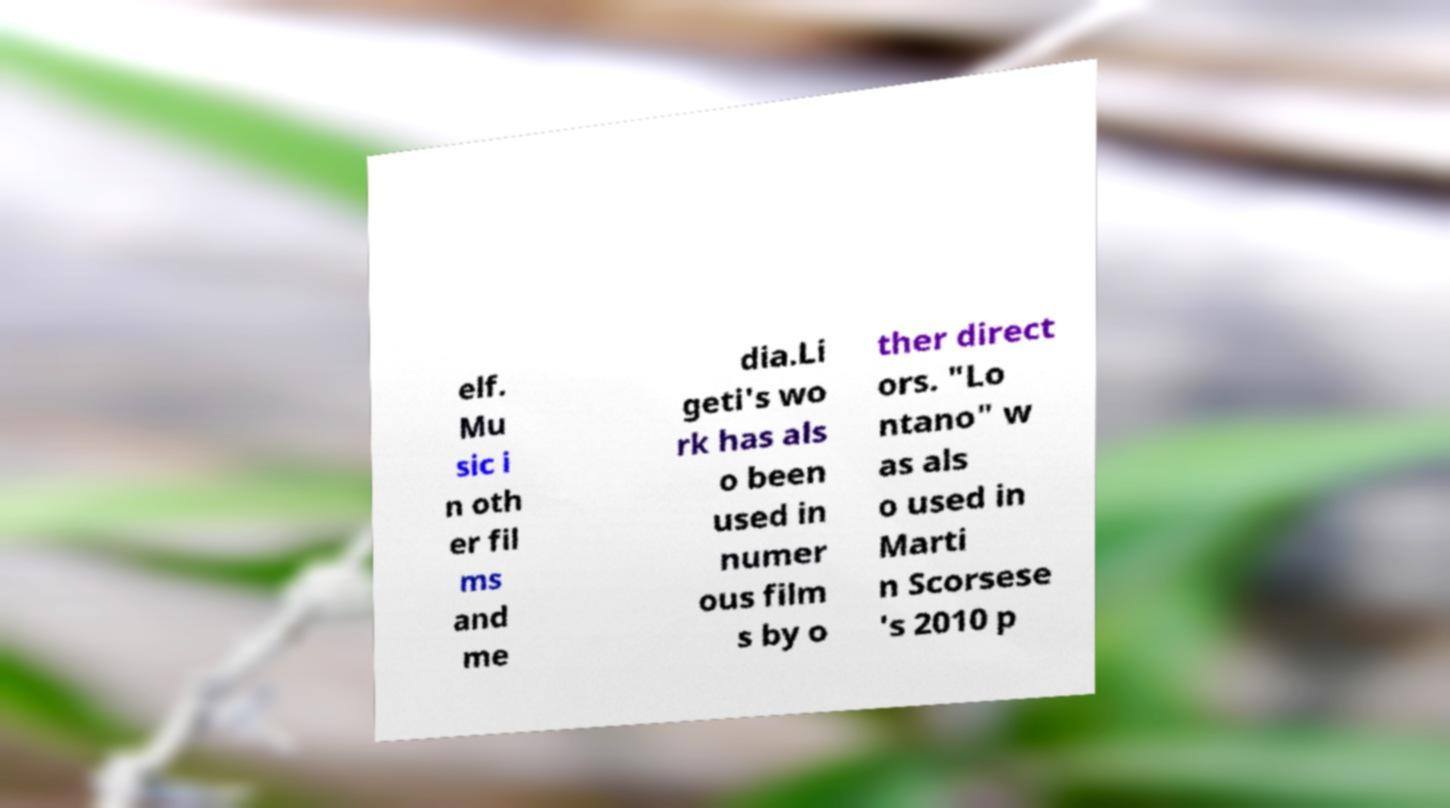I need the written content from this picture converted into text. Can you do that? elf. Mu sic i n oth er fil ms and me dia.Li geti's wo rk has als o been used in numer ous film s by o ther direct ors. "Lo ntano" w as als o used in Marti n Scorsese 's 2010 p 